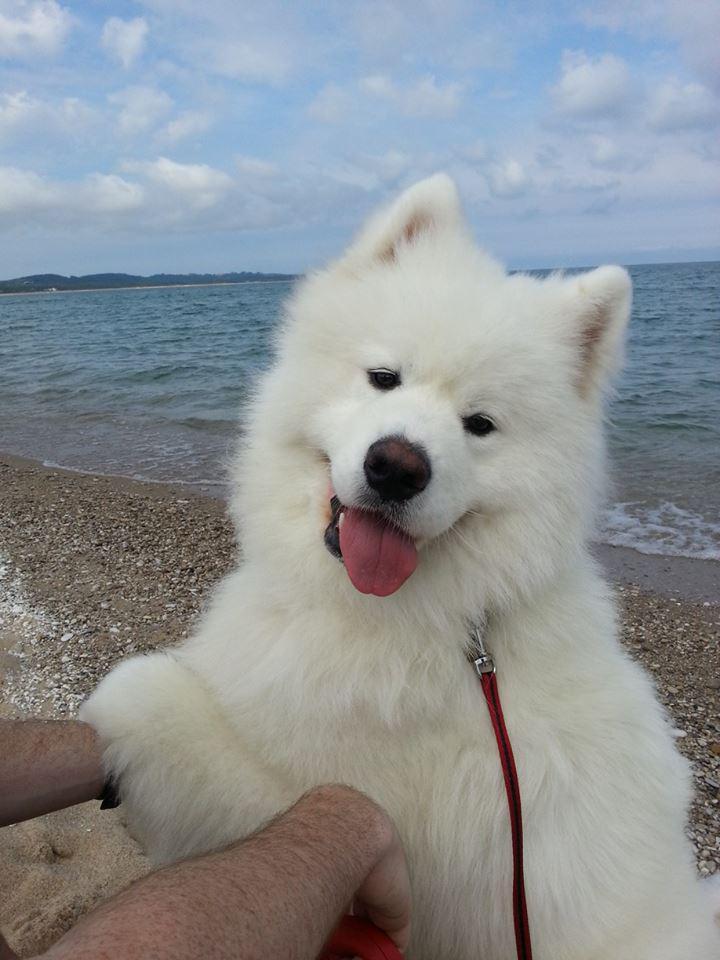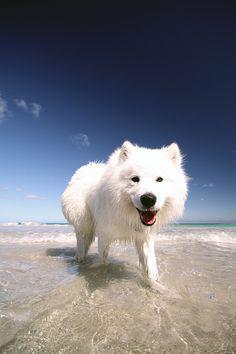The first image is the image on the left, the second image is the image on the right. Evaluate the accuracy of this statement regarding the images: "At least one dog is standing on asphalt.". Is it true? Answer yes or no. No. 